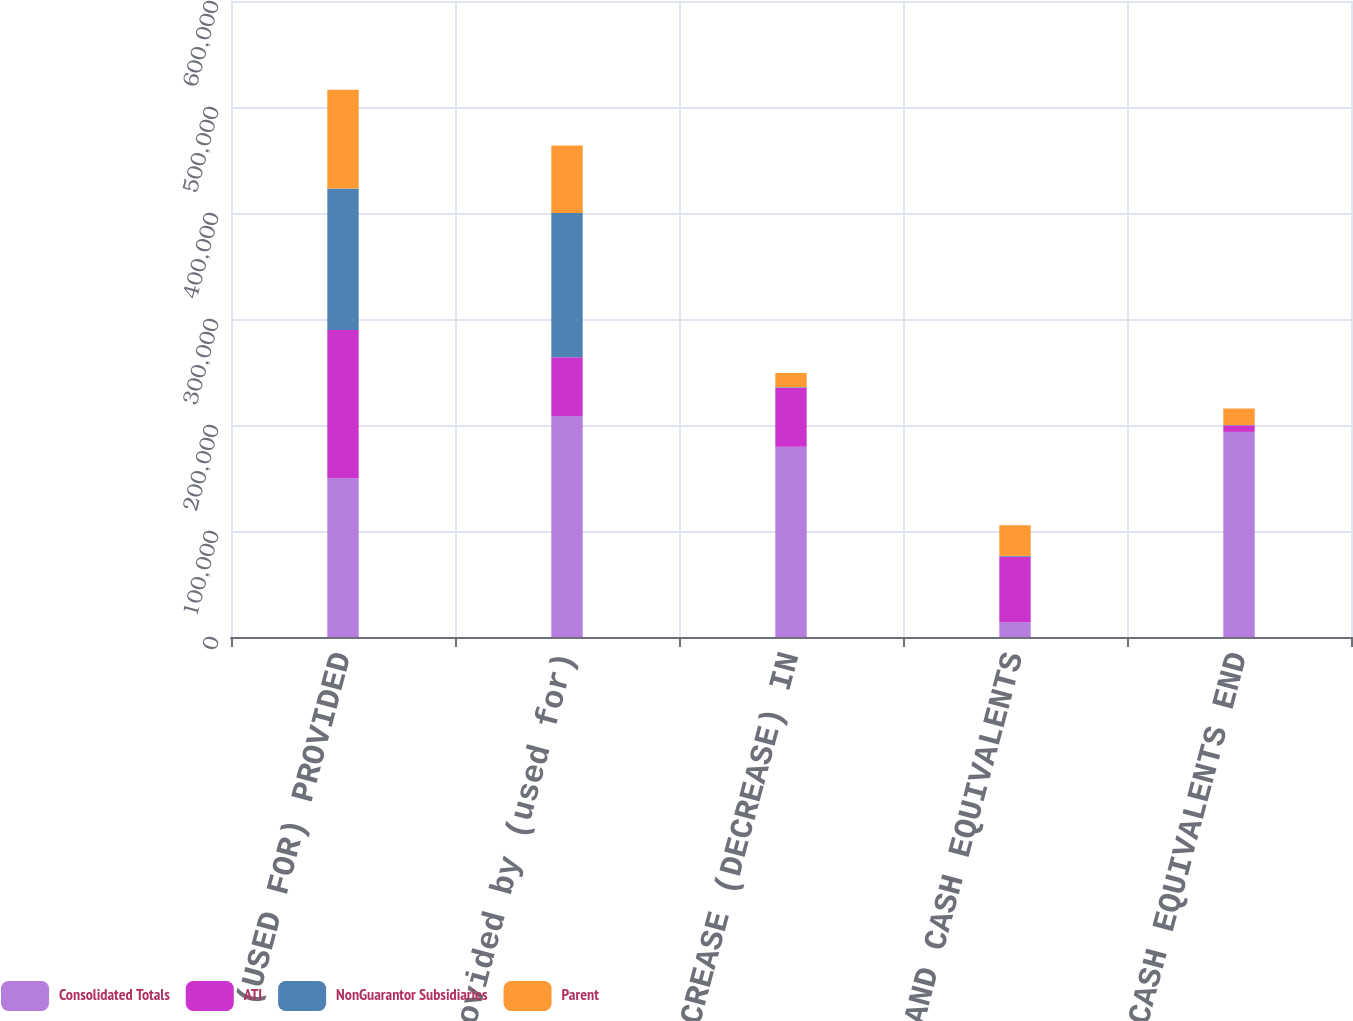<chart> <loc_0><loc_0><loc_500><loc_500><stacked_bar_chart><ecel><fcel>CASH FLOWS (USED FOR) PROVIDED<fcel>Cash provided by (used for)<fcel>NET INCREASE (DECREASE) IN<fcel>CASH AND CASH EQUIVALENTS<fcel>CASH AND CASH EQUIVALENTS END<nl><fcel>Consolidated Totals<fcel>149729<fcel>208380<fcel>179566<fcel>13917<fcel>193483<nl><fcel>ATI<fcel>139876<fcel>55635<fcel>55635<fcel>61809<fcel>6174<nl><fcel>NonGuarantor Subsidiaries<fcel>133393<fcel>136100<fcel>529<fcel>836<fcel>307<nl><fcel>Parent<fcel>93160<fcel>63640<fcel>13310<fcel>28903<fcel>15593<nl></chart> 